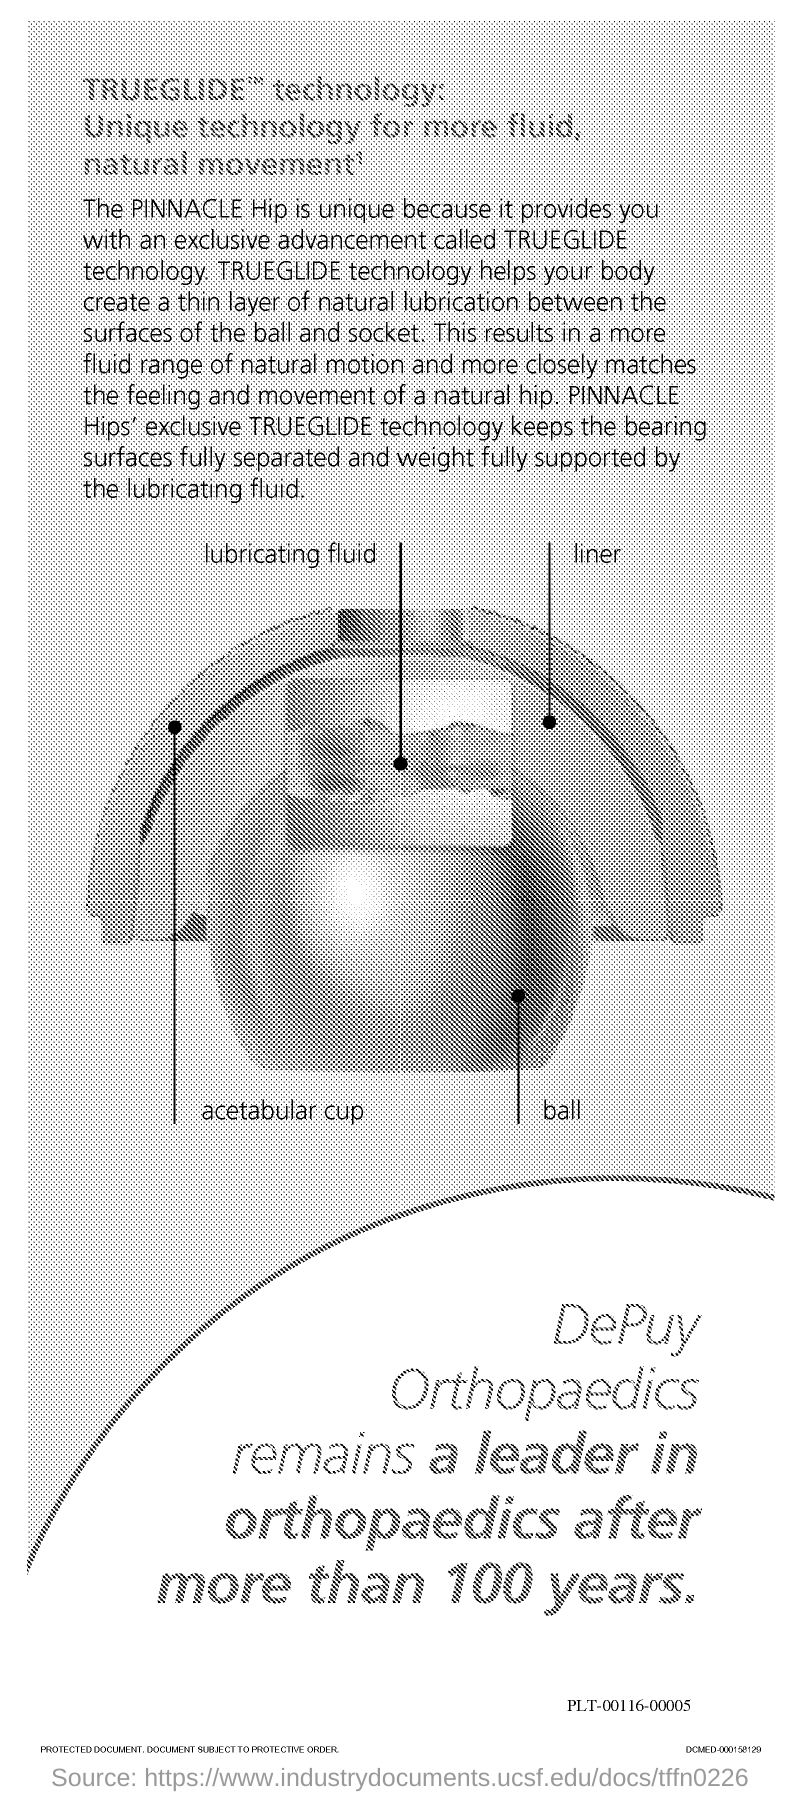List a handful of essential elements in this visual. Pinnacle hip implants are unique due to their use of TRUEGLIDE technology, which provides increased stability and range of motion compared to traditional hip implants. TRUEGLIDE technology provides a thin layer of natural lubrication between the ball and socket, ensuring smooth and effortless movement, reducing friction and increasing the stability of the artificial joint. TRUEGLIDE technology is the name of the technology specified in the title of this page. Introducing PINNACLE hips featuring the exclusive Trueglide Technology, a cutting-edge innovation in total hip replacement that ensures smooth and efficient movement with reduced friction and increased longevity. PINNACLE Hip is unique because it features the innovative TRUeGLIDE technology, offering an exclusive advancement in hip replacement surgery. 